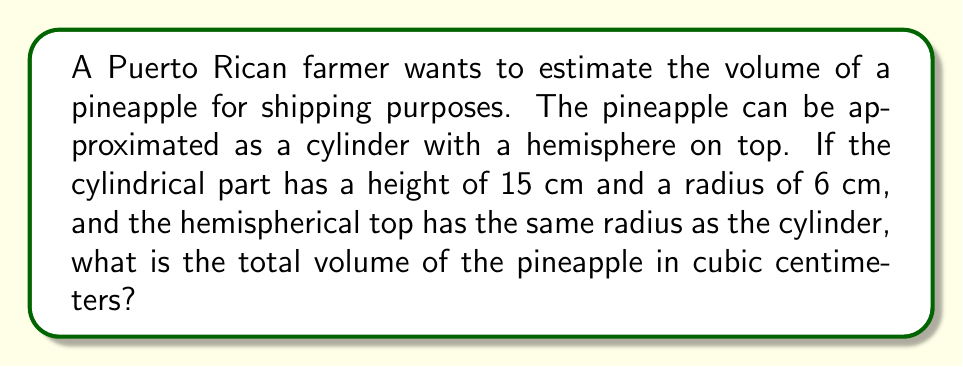Solve this math problem. Let's break this down step-by-step:

1) First, we need to calculate the volume of the cylindrical part:
   The formula for the volume of a cylinder is $V_{cylinder} = \pi r^2 h$
   Where $r$ is the radius and $h$ is the height.
   
   $V_{cylinder} = \pi (6 \text{ cm})^2 (15 \text{ cm})$
   $V_{cylinder} = \pi (36 \text{ cm}^2) (15 \text{ cm})$
   $V_{cylinder} = 540\pi \text{ cm}^3$

2) Next, we calculate the volume of the hemispherical top:
   The formula for the volume of a hemisphere is $V_{hemisphere} = \frac{2}{3}\pi r^3$
   
   $V_{hemisphere} = \frac{2}{3}\pi (6 \text{ cm})^3$
   $V_{hemisphere} = \frac{2}{3}\pi (216 \text{ cm}^3)$
   $V_{hemisphere} = 144\pi \text{ cm}^3$

3) The total volume is the sum of these two parts:
   $V_{total} = V_{cylinder} + V_{hemisphere}$
   $V_{total} = 540\pi \text{ cm}^3 + 144\pi \text{ cm}^3$
   $V_{total} = 684\pi \text{ cm}^3$

4) If we want to give a decimal approximation:
   $V_{total} \approx 2,149.23 \text{ cm}^3$

[asy]
import three;

size(200);
currentprojection=perspective(6,3,2);

// Draw cylinder
path3 p=circle((0,0,0),6);
path3 q=circle((0,0,15),6);
draw(surface(p--q--cycle),palegreen+opacity(.5));

// Draw hemisphere
draw(shift((0,0,15))*surface(sphere((0,0,0),6)),yellow+opacity(.5));

// Draw axes
draw((0,0,0)--(10,0,0),arrow=Arrow3);
draw((0,0,0)--(0,10,0),arrow=Arrow3);
draw((0,0,0)--(0,0,20),arrow=Arrow3);

label("x",(10,0,0),E);
label("y",(0,10,0),N);
label("z",(0,0,20),W);

[/asy]
Answer: $684\pi \text{ cm}^3$ or approximately $2,149.23 \text{ cm}^3$ 